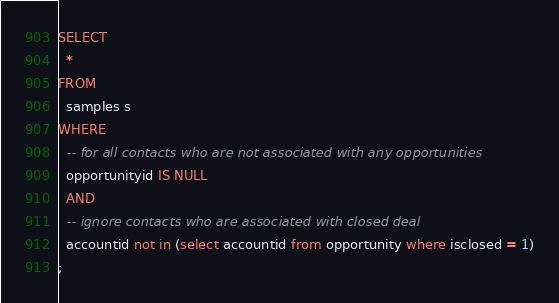<code> <loc_0><loc_0><loc_500><loc_500><_SQL_>SELECT
  *
FROM
  samples s
WHERE
  -- for all contacts who are not associated with any opportunities
  opportunityid IS NULL
  AND
  -- ignore contacts who are associated with closed deal
  accountid not in (select accountid from opportunity where isclosed = 1)
;
</code> 